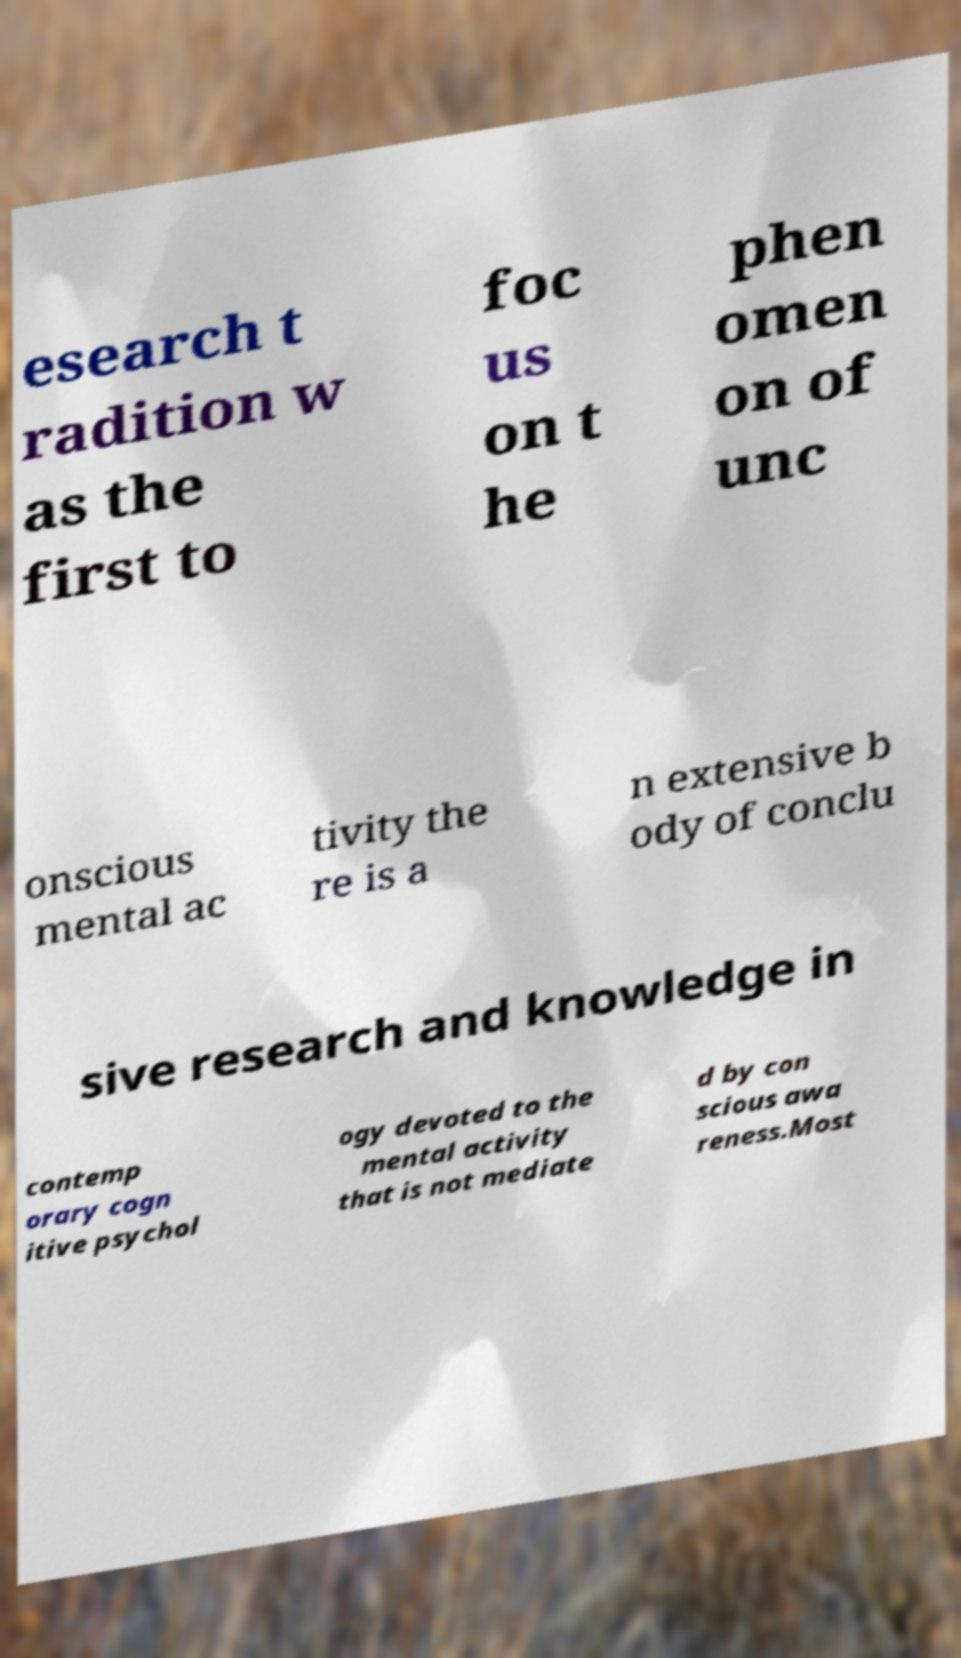I need the written content from this picture converted into text. Can you do that? esearch t radition w as the first to foc us on t he phen omen on of unc onscious mental ac tivity the re is a n extensive b ody of conclu sive research and knowledge in contemp orary cogn itive psychol ogy devoted to the mental activity that is not mediate d by con scious awa reness.Most 